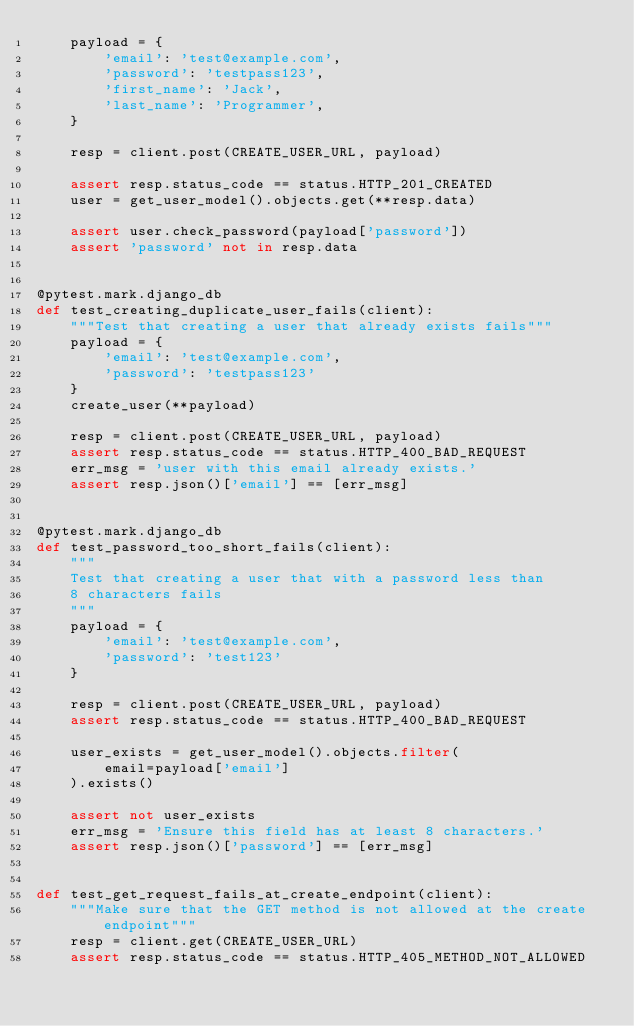Convert code to text. <code><loc_0><loc_0><loc_500><loc_500><_Python_>    payload = {
        'email': 'test@example.com',
        'password': 'testpass123',
        'first_name': 'Jack',
        'last_name': 'Programmer',
    }

    resp = client.post(CREATE_USER_URL, payload)

    assert resp.status_code == status.HTTP_201_CREATED
    user = get_user_model().objects.get(**resp.data)

    assert user.check_password(payload['password'])
    assert 'password' not in resp.data


@pytest.mark.django_db
def test_creating_duplicate_user_fails(client):
    """Test that creating a user that already exists fails"""
    payload = {
        'email': 'test@example.com',
        'password': 'testpass123'
    }
    create_user(**payload)

    resp = client.post(CREATE_USER_URL, payload)
    assert resp.status_code == status.HTTP_400_BAD_REQUEST
    err_msg = 'user with this email already exists.'
    assert resp.json()['email'] == [err_msg]


@pytest.mark.django_db
def test_password_too_short_fails(client):
    """
    Test that creating a user that with a password less than
    8 characters fails
    """
    payload = {
        'email': 'test@example.com',
        'password': 'test123'
    }

    resp = client.post(CREATE_USER_URL, payload)
    assert resp.status_code == status.HTTP_400_BAD_REQUEST

    user_exists = get_user_model().objects.filter(
        email=payload['email']
    ).exists()

    assert not user_exists
    err_msg = 'Ensure this field has at least 8 characters.'
    assert resp.json()['password'] == [err_msg]


def test_get_request_fails_at_create_endpoint(client):
    """Make sure that the GET method is not allowed at the create endpoint"""
    resp = client.get(CREATE_USER_URL)
    assert resp.status_code == status.HTTP_405_METHOD_NOT_ALLOWED
</code> 